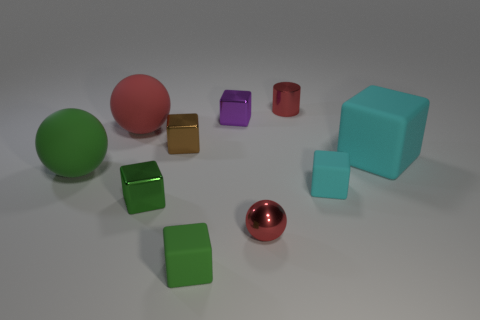There is a cube on the left side of the small brown block; is it the same color as the tiny matte block that is in front of the tiny green metal object?
Keep it short and to the point. Yes. There is a cylinder that is the same color as the tiny metal sphere; what size is it?
Your answer should be compact. Small. Is there a tiny purple object that has the same material as the cylinder?
Your response must be concise. Yes. What is the color of the metal ball?
Offer a terse response. Red. What size is the red thing that is on the left side of the small rubber block in front of the green block to the left of the tiny brown metallic cube?
Provide a succinct answer. Large. How many other objects are the same shape as the big cyan object?
Your response must be concise. 5. There is a sphere that is on the left side of the red metallic sphere and right of the green rubber ball; what is its color?
Provide a short and direct response. Red. Do the matte sphere that is right of the large green rubber sphere and the small shiny cylinder have the same color?
Offer a terse response. Yes. What number of blocks are small gray metal things or green things?
Keep it short and to the point. 2. The red metal object in front of the tiny cyan cube has what shape?
Your response must be concise. Sphere. 